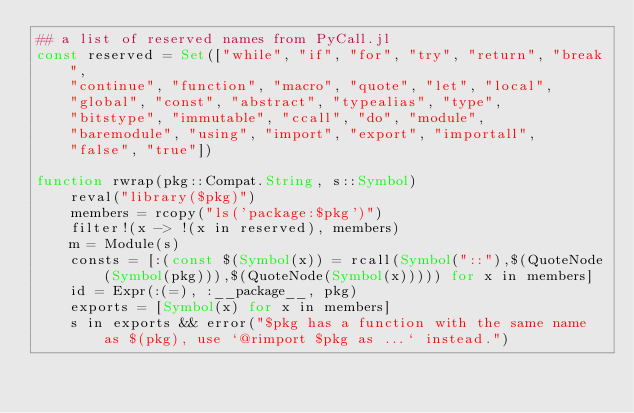<code> <loc_0><loc_0><loc_500><loc_500><_Julia_>## a list of reserved names from PyCall.jl
const reserved = Set(["while", "if", "for", "try", "return", "break",
    "continue", "function", "macro", "quote", "let", "local",
    "global", "const", "abstract", "typealias", "type",
    "bitstype", "immutable", "ccall", "do", "module",
    "baremodule", "using", "import", "export", "importall",
    "false", "true"])

function rwrap(pkg::Compat.String, s::Symbol)
    reval("library($pkg)")
    members = rcopy("ls('package:$pkg')")
    filter!(x -> !(x in reserved), members)
    m = Module(s)
    consts = [:(const $(Symbol(x)) = rcall(Symbol("::"),$(QuoteNode(Symbol(pkg))),$(QuoteNode(Symbol(x))))) for x in members]
    id = Expr(:(=), :__package__, pkg)
    exports = [Symbol(x) for x in members]
    s in exports && error("$pkg has a function with the same name as $(pkg), use `@rimport $pkg as ...` instead.")</code> 